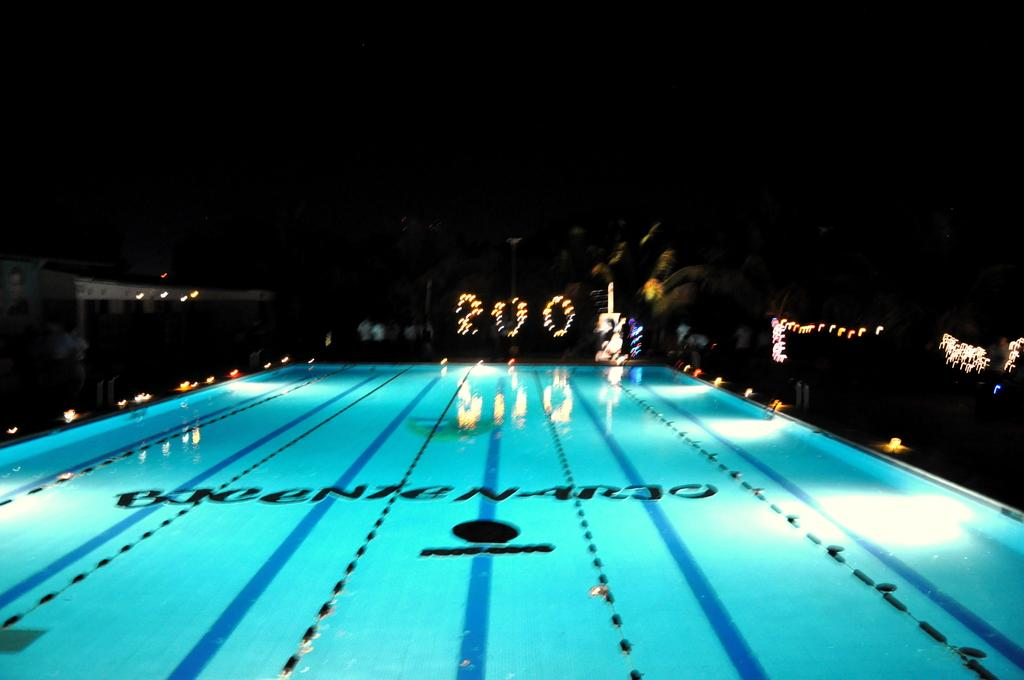What is the main subject in the center of the image? There is a swimming pool in the center of the image. Can you describe the swimming pool in the image? The swimming pool is the main subject in the center of the image. What part of the government is responsible for maintaining the swimming pool in the image? There is no information about the government or its involvement in the image, as it only features a swimming pool. 